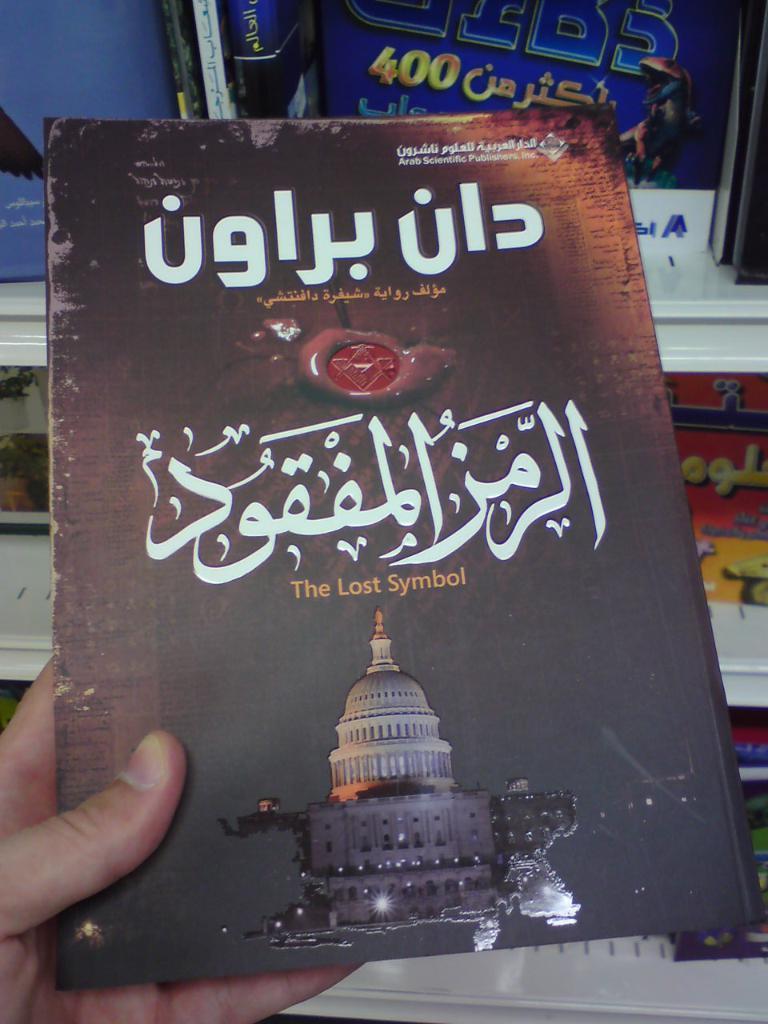What was lost?
Offer a terse response. Symbol. 